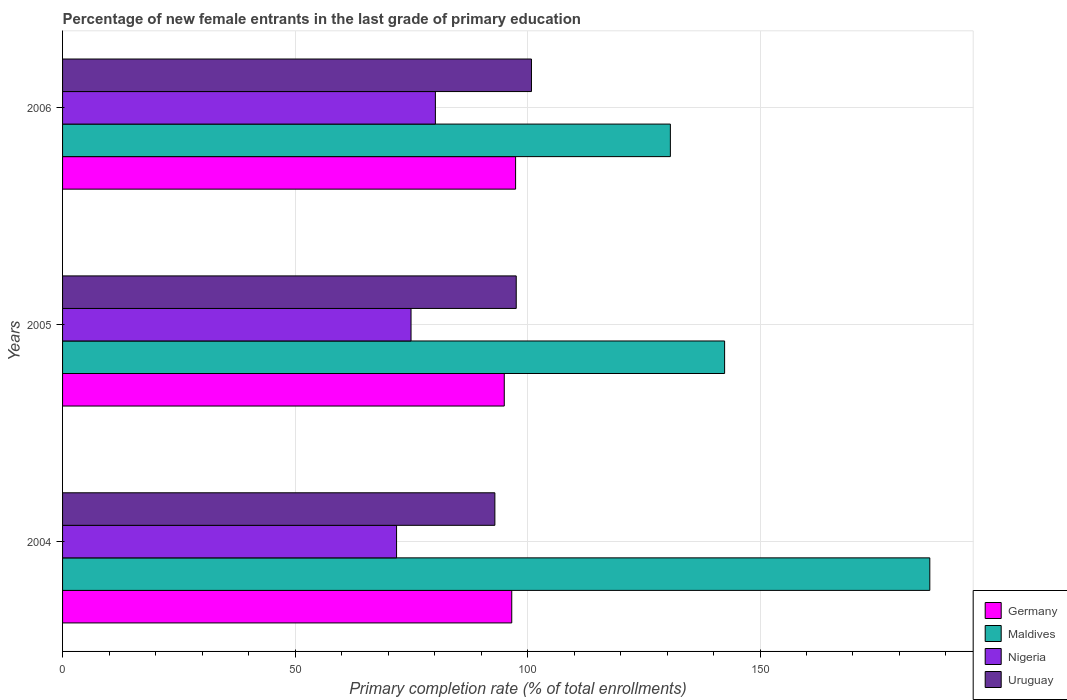How many different coloured bars are there?
Provide a succinct answer. 4. Are the number of bars on each tick of the Y-axis equal?
Keep it short and to the point. Yes. How many bars are there on the 3rd tick from the top?
Ensure brevity in your answer.  4. How many bars are there on the 2nd tick from the bottom?
Your answer should be very brief. 4. In how many cases, is the number of bars for a given year not equal to the number of legend labels?
Make the answer very short. 0. What is the percentage of new female entrants in Nigeria in 2006?
Offer a very short reply. 80.19. Across all years, what is the maximum percentage of new female entrants in Uruguay?
Provide a short and direct response. 100.85. Across all years, what is the minimum percentage of new female entrants in Germany?
Your response must be concise. 95. In which year was the percentage of new female entrants in Uruguay maximum?
Your response must be concise. 2006. What is the total percentage of new female entrants in Maldives in the graph?
Offer a very short reply. 459.64. What is the difference between the percentage of new female entrants in Germany in 2005 and that in 2006?
Provide a succinct answer. -2.43. What is the difference between the percentage of new female entrants in Uruguay in 2006 and the percentage of new female entrants in Germany in 2005?
Provide a short and direct response. 5.85. What is the average percentage of new female entrants in Uruguay per year?
Give a very brief answer. 97.13. In the year 2005, what is the difference between the percentage of new female entrants in Maldives and percentage of new female entrants in Germany?
Offer a terse response. 47.39. What is the ratio of the percentage of new female entrants in Uruguay in 2005 to that in 2006?
Offer a very short reply. 0.97. Is the difference between the percentage of new female entrants in Maldives in 2004 and 2006 greater than the difference between the percentage of new female entrants in Germany in 2004 and 2006?
Keep it short and to the point. Yes. What is the difference between the highest and the second highest percentage of new female entrants in Germany?
Your answer should be very brief. 0.83. What is the difference between the highest and the lowest percentage of new female entrants in Nigeria?
Offer a terse response. 8.35. In how many years, is the percentage of new female entrants in Uruguay greater than the average percentage of new female entrants in Uruguay taken over all years?
Your answer should be compact. 2. Is it the case that in every year, the sum of the percentage of new female entrants in Nigeria and percentage of new female entrants in Maldives is greater than the sum of percentage of new female entrants in Uruguay and percentage of new female entrants in Germany?
Make the answer very short. Yes. What does the 1st bar from the top in 2005 represents?
Make the answer very short. Uruguay. What does the 4th bar from the bottom in 2005 represents?
Give a very brief answer. Uruguay. Is it the case that in every year, the sum of the percentage of new female entrants in Maldives and percentage of new female entrants in Germany is greater than the percentage of new female entrants in Nigeria?
Your answer should be compact. Yes. How many bars are there?
Your answer should be very brief. 12. Are all the bars in the graph horizontal?
Provide a succinct answer. Yes. How many years are there in the graph?
Give a very brief answer. 3. Are the values on the major ticks of X-axis written in scientific E-notation?
Your response must be concise. No. Does the graph contain grids?
Offer a terse response. Yes. How many legend labels are there?
Offer a very short reply. 4. What is the title of the graph?
Provide a short and direct response. Percentage of new female entrants in the last grade of primary education. What is the label or title of the X-axis?
Your answer should be compact. Primary completion rate (% of total enrollments). What is the Primary completion rate (% of total enrollments) in Germany in 2004?
Your answer should be very brief. 96.61. What is the Primary completion rate (% of total enrollments) in Maldives in 2004?
Your answer should be very brief. 186.52. What is the Primary completion rate (% of total enrollments) in Nigeria in 2004?
Give a very brief answer. 71.84. What is the Primary completion rate (% of total enrollments) in Uruguay in 2004?
Make the answer very short. 92.98. What is the Primary completion rate (% of total enrollments) of Germany in 2005?
Ensure brevity in your answer.  95. What is the Primary completion rate (% of total enrollments) in Maldives in 2005?
Give a very brief answer. 142.39. What is the Primary completion rate (% of total enrollments) in Nigeria in 2005?
Offer a very short reply. 74.95. What is the Primary completion rate (% of total enrollments) of Uruguay in 2005?
Your response must be concise. 97.57. What is the Primary completion rate (% of total enrollments) in Germany in 2006?
Ensure brevity in your answer.  97.43. What is the Primary completion rate (% of total enrollments) of Maldives in 2006?
Give a very brief answer. 130.73. What is the Primary completion rate (% of total enrollments) of Nigeria in 2006?
Offer a terse response. 80.19. What is the Primary completion rate (% of total enrollments) in Uruguay in 2006?
Keep it short and to the point. 100.85. Across all years, what is the maximum Primary completion rate (% of total enrollments) in Germany?
Offer a very short reply. 97.43. Across all years, what is the maximum Primary completion rate (% of total enrollments) of Maldives?
Make the answer very short. 186.52. Across all years, what is the maximum Primary completion rate (% of total enrollments) in Nigeria?
Your response must be concise. 80.19. Across all years, what is the maximum Primary completion rate (% of total enrollments) of Uruguay?
Offer a terse response. 100.85. Across all years, what is the minimum Primary completion rate (% of total enrollments) of Germany?
Make the answer very short. 95. Across all years, what is the minimum Primary completion rate (% of total enrollments) of Maldives?
Keep it short and to the point. 130.73. Across all years, what is the minimum Primary completion rate (% of total enrollments) in Nigeria?
Offer a terse response. 71.84. Across all years, what is the minimum Primary completion rate (% of total enrollments) of Uruguay?
Offer a terse response. 92.98. What is the total Primary completion rate (% of total enrollments) in Germany in the graph?
Your answer should be very brief. 289.04. What is the total Primary completion rate (% of total enrollments) in Maldives in the graph?
Make the answer very short. 459.64. What is the total Primary completion rate (% of total enrollments) of Nigeria in the graph?
Give a very brief answer. 226.97. What is the total Primary completion rate (% of total enrollments) in Uruguay in the graph?
Provide a short and direct response. 291.4. What is the difference between the Primary completion rate (% of total enrollments) in Germany in 2004 and that in 2005?
Your response must be concise. 1.61. What is the difference between the Primary completion rate (% of total enrollments) of Maldives in 2004 and that in 2005?
Your answer should be very brief. 44.13. What is the difference between the Primary completion rate (% of total enrollments) in Nigeria in 2004 and that in 2005?
Offer a terse response. -3.11. What is the difference between the Primary completion rate (% of total enrollments) of Uruguay in 2004 and that in 2005?
Offer a very short reply. -4.59. What is the difference between the Primary completion rate (% of total enrollments) of Germany in 2004 and that in 2006?
Offer a terse response. -0.83. What is the difference between the Primary completion rate (% of total enrollments) of Maldives in 2004 and that in 2006?
Provide a short and direct response. 55.8. What is the difference between the Primary completion rate (% of total enrollments) of Nigeria in 2004 and that in 2006?
Your answer should be compact. -8.35. What is the difference between the Primary completion rate (% of total enrollments) in Uruguay in 2004 and that in 2006?
Give a very brief answer. -7.87. What is the difference between the Primary completion rate (% of total enrollments) of Germany in 2005 and that in 2006?
Your response must be concise. -2.43. What is the difference between the Primary completion rate (% of total enrollments) in Maldives in 2005 and that in 2006?
Make the answer very short. 11.66. What is the difference between the Primary completion rate (% of total enrollments) in Nigeria in 2005 and that in 2006?
Your answer should be compact. -5.24. What is the difference between the Primary completion rate (% of total enrollments) in Uruguay in 2005 and that in 2006?
Offer a very short reply. -3.28. What is the difference between the Primary completion rate (% of total enrollments) in Germany in 2004 and the Primary completion rate (% of total enrollments) in Maldives in 2005?
Give a very brief answer. -45.78. What is the difference between the Primary completion rate (% of total enrollments) in Germany in 2004 and the Primary completion rate (% of total enrollments) in Nigeria in 2005?
Give a very brief answer. 21.66. What is the difference between the Primary completion rate (% of total enrollments) of Germany in 2004 and the Primary completion rate (% of total enrollments) of Uruguay in 2005?
Your answer should be very brief. -0.96. What is the difference between the Primary completion rate (% of total enrollments) of Maldives in 2004 and the Primary completion rate (% of total enrollments) of Nigeria in 2005?
Offer a very short reply. 111.58. What is the difference between the Primary completion rate (% of total enrollments) in Maldives in 2004 and the Primary completion rate (% of total enrollments) in Uruguay in 2005?
Provide a short and direct response. 88.95. What is the difference between the Primary completion rate (% of total enrollments) of Nigeria in 2004 and the Primary completion rate (% of total enrollments) of Uruguay in 2005?
Provide a short and direct response. -25.74. What is the difference between the Primary completion rate (% of total enrollments) of Germany in 2004 and the Primary completion rate (% of total enrollments) of Maldives in 2006?
Your answer should be compact. -34.12. What is the difference between the Primary completion rate (% of total enrollments) in Germany in 2004 and the Primary completion rate (% of total enrollments) in Nigeria in 2006?
Offer a very short reply. 16.42. What is the difference between the Primary completion rate (% of total enrollments) of Germany in 2004 and the Primary completion rate (% of total enrollments) of Uruguay in 2006?
Your answer should be compact. -4.24. What is the difference between the Primary completion rate (% of total enrollments) in Maldives in 2004 and the Primary completion rate (% of total enrollments) in Nigeria in 2006?
Offer a terse response. 106.34. What is the difference between the Primary completion rate (% of total enrollments) in Maldives in 2004 and the Primary completion rate (% of total enrollments) in Uruguay in 2006?
Keep it short and to the point. 85.68. What is the difference between the Primary completion rate (% of total enrollments) of Nigeria in 2004 and the Primary completion rate (% of total enrollments) of Uruguay in 2006?
Offer a terse response. -29.01. What is the difference between the Primary completion rate (% of total enrollments) of Germany in 2005 and the Primary completion rate (% of total enrollments) of Maldives in 2006?
Offer a terse response. -35.73. What is the difference between the Primary completion rate (% of total enrollments) in Germany in 2005 and the Primary completion rate (% of total enrollments) in Nigeria in 2006?
Keep it short and to the point. 14.81. What is the difference between the Primary completion rate (% of total enrollments) of Germany in 2005 and the Primary completion rate (% of total enrollments) of Uruguay in 2006?
Your answer should be very brief. -5.85. What is the difference between the Primary completion rate (% of total enrollments) of Maldives in 2005 and the Primary completion rate (% of total enrollments) of Nigeria in 2006?
Ensure brevity in your answer.  62.2. What is the difference between the Primary completion rate (% of total enrollments) of Maldives in 2005 and the Primary completion rate (% of total enrollments) of Uruguay in 2006?
Your answer should be compact. 41.54. What is the difference between the Primary completion rate (% of total enrollments) in Nigeria in 2005 and the Primary completion rate (% of total enrollments) in Uruguay in 2006?
Your response must be concise. -25.9. What is the average Primary completion rate (% of total enrollments) of Germany per year?
Give a very brief answer. 96.35. What is the average Primary completion rate (% of total enrollments) of Maldives per year?
Your response must be concise. 153.21. What is the average Primary completion rate (% of total enrollments) of Nigeria per year?
Offer a very short reply. 75.66. What is the average Primary completion rate (% of total enrollments) in Uruguay per year?
Make the answer very short. 97.13. In the year 2004, what is the difference between the Primary completion rate (% of total enrollments) in Germany and Primary completion rate (% of total enrollments) in Maldives?
Your answer should be compact. -89.92. In the year 2004, what is the difference between the Primary completion rate (% of total enrollments) in Germany and Primary completion rate (% of total enrollments) in Nigeria?
Offer a terse response. 24.77. In the year 2004, what is the difference between the Primary completion rate (% of total enrollments) in Germany and Primary completion rate (% of total enrollments) in Uruguay?
Provide a succinct answer. 3.63. In the year 2004, what is the difference between the Primary completion rate (% of total enrollments) of Maldives and Primary completion rate (% of total enrollments) of Nigeria?
Provide a short and direct response. 114.69. In the year 2004, what is the difference between the Primary completion rate (% of total enrollments) in Maldives and Primary completion rate (% of total enrollments) in Uruguay?
Ensure brevity in your answer.  93.55. In the year 2004, what is the difference between the Primary completion rate (% of total enrollments) of Nigeria and Primary completion rate (% of total enrollments) of Uruguay?
Your response must be concise. -21.14. In the year 2005, what is the difference between the Primary completion rate (% of total enrollments) of Germany and Primary completion rate (% of total enrollments) of Maldives?
Your answer should be very brief. -47.39. In the year 2005, what is the difference between the Primary completion rate (% of total enrollments) of Germany and Primary completion rate (% of total enrollments) of Nigeria?
Provide a short and direct response. 20.05. In the year 2005, what is the difference between the Primary completion rate (% of total enrollments) in Germany and Primary completion rate (% of total enrollments) in Uruguay?
Give a very brief answer. -2.57. In the year 2005, what is the difference between the Primary completion rate (% of total enrollments) of Maldives and Primary completion rate (% of total enrollments) of Nigeria?
Your answer should be very brief. 67.44. In the year 2005, what is the difference between the Primary completion rate (% of total enrollments) in Maldives and Primary completion rate (% of total enrollments) in Uruguay?
Keep it short and to the point. 44.82. In the year 2005, what is the difference between the Primary completion rate (% of total enrollments) in Nigeria and Primary completion rate (% of total enrollments) in Uruguay?
Offer a very short reply. -22.63. In the year 2006, what is the difference between the Primary completion rate (% of total enrollments) in Germany and Primary completion rate (% of total enrollments) in Maldives?
Ensure brevity in your answer.  -33.29. In the year 2006, what is the difference between the Primary completion rate (% of total enrollments) in Germany and Primary completion rate (% of total enrollments) in Nigeria?
Your response must be concise. 17.25. In the year 2006, what is the difference between the Primary completion rate (% of total enrollments) in Germany and Primary completion rate (% of total enrollments) in Uruguay?
Offer a very short reply. -3.41. In the year 2006, what is the difference between the Primary completion rate (% of total enrollments) of Maldives and Primary completion rate (% of total enrollments) of Nigeria?
Give a very brief answer. 50.54. In the year 2006, what is the difference between the Primary completion rate (% of total enrollments) of Maldives and Primary completion rate (% of total enrollments) of Uruguay?
Your answer should be compact. 29.88. In the year 2006, what is the difference between the Primary completion rate (% of total enrollments) of Nigeria and Primary completion rate (% of total enrollments) of Uruguay?
Offer a terse response. -20.66. What is the ratio of the Primary completion rate (% of total enrollments) of Germany in 2004 to that in 2005?
Provide a succinct answer. 1.02. What is the ratio of the Primary completion rate (% of total enrollments) of Maldives in 2004 to that in 2005?
Offer a terse response. 1.31. What is the ratio of the Primary completion rate (% of total enrollments) of Nigeria in 2004 to that in 2005?
Your answer should be compact. 0.96. What is the ratio of the Primary completion rate (% of total enrollments) of Uruguay in 2004 to that in 2005?
Provide a succinct answer. 0.95. What is the ratio of the Primary completion rate (% of total enrollments) of Maldives in 2004 to that in 2006?
Offer a very short reply. 1.43. What is the ratio of the Primary completion rate (% of total enrollments) in Nigeria in 2004 to that in 2006?
Provide a succinct answer. 0.9. What is the ratio of the Primary completion rate (% of total enrollments) of Uruguay in 2004 to that in 2006?
Your response must be concise. 0.92. What is the ratio of the Primary completion rate (% of total enrollments) of Germany in 2005 to that in 2006?
Your answer should be very brief. 0.97. What is the ratio of the Primary completion rate (% of total enrollments) in Maldives in 2005 to that in 2006?
Your response must be concise. 1.09. What is the ratio of the Primary completion rate (% of total enrollments) of Nigeria in 2005 to that in 2006?
Keep it short and to the point. 0.93. What is the ratio of the Primary completion rate (% of total enrollments) of Uruguay in 2005 to that in 2006?
Provide a succinct answer. 0.97. What is the difference between the highest and the second highest Primary completion rate (% of total enrollments) in Germany?
Provide a short and direct response. 0.83. What is the difference between the highest and the second highest Primary completion rate (% of total enrollments) of Maldives?
Provide a short and direct response. 44.13. What is the difference between the highest and the second highest Primary completion rate (% of total enrollments) in Nigeria?
Provide a short and direct response. 5.24. What is the difference between the highest and the second highest Primary completion rate (% of total enrollments) in Uruguay?
Your answer should be compact. 3.28. What is the difference between the highest and the lowest Primary completion rate (% of total enrollments) in Germany?
Ensure brevity in your answer.  2.43. What is the difference between the highest and the lowest Primary completion rate (% of total enrollments) in Maldives?
Make the answer very short. 55.8. What is the difference between the highest and the lowest Primary completion rate (% of total enrollments) of Nigeria?
Your answer should be compact. 8.35. What is the difference between the highest and the lowest Primary completion rate (% of total enrollments) in Uruguay?
Your response must be concise. 7.87. 